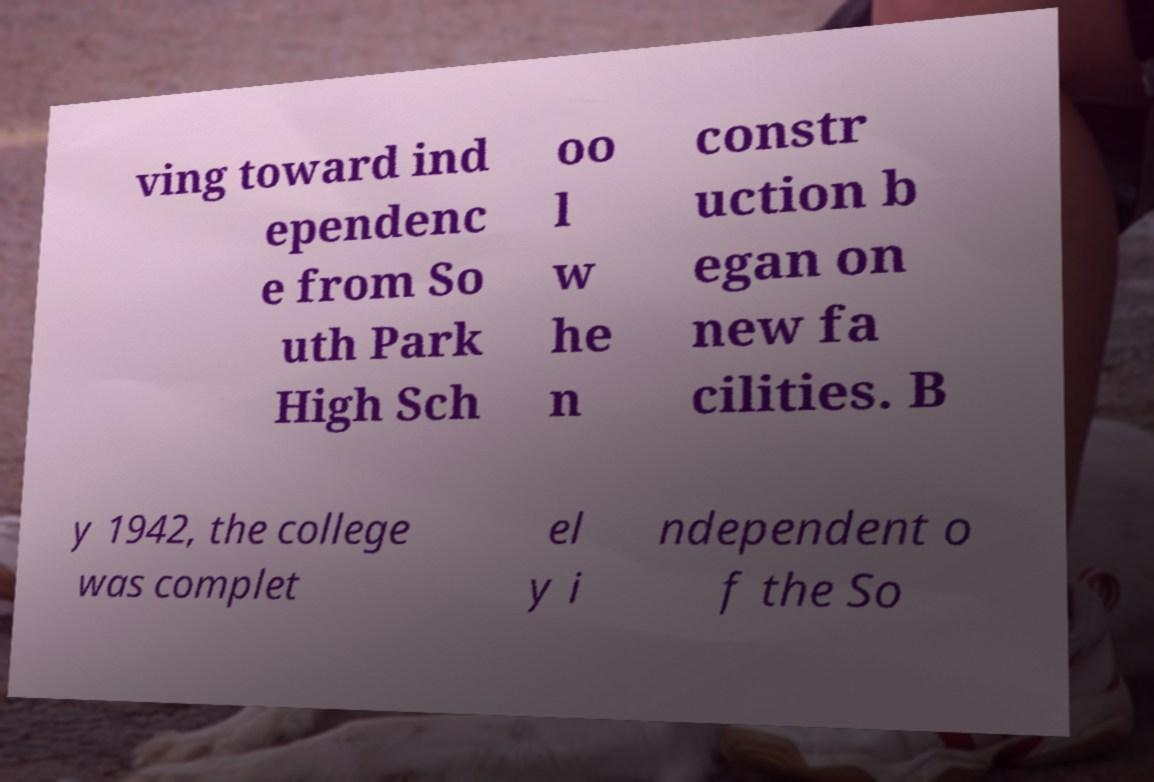Please identify and transcribe the text found in this image. ving toward ind ependenc e from So uth Park High Sch oo l w he n constr uction b egan on new fa cilities. B y 1942, the college was complet el y i ndependent o f the So 